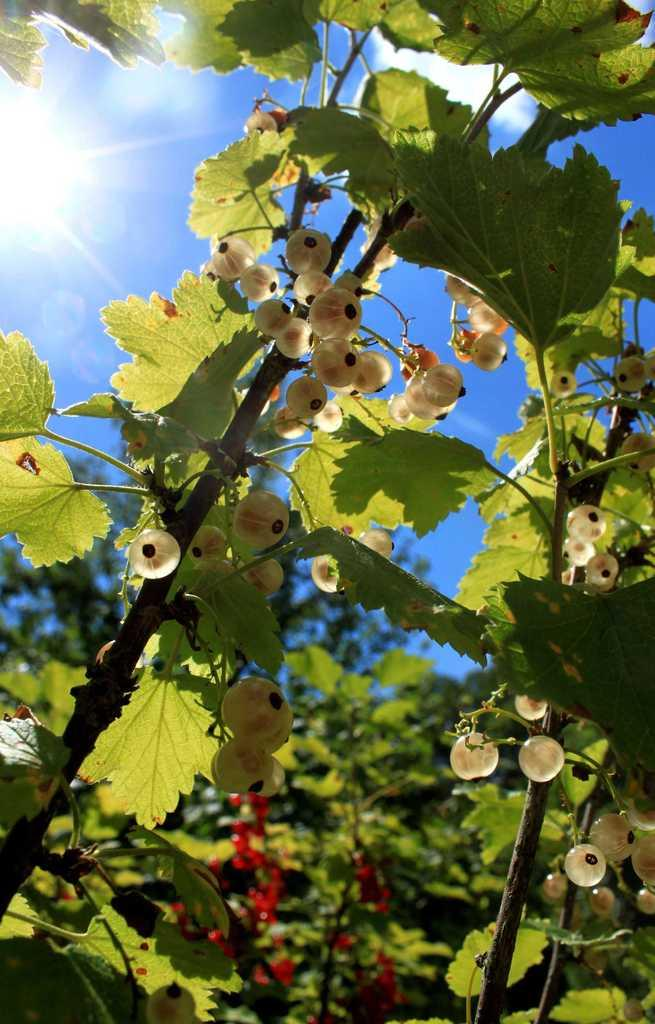What type of vegetation is present in the image? There are trees with fruits in the image. What is the color of the sky in the image? The sky is blue in the image. Can you describe the lighting conditions in the image? Sunlight is visible in the sky, indicating that it is daytime. Is there a snake slithering through the trees in the image? No, there is no snake present in the image. What type of base can be seen supporting the trees in the image? There is no base visible in the image; the trees are growing naturally. 